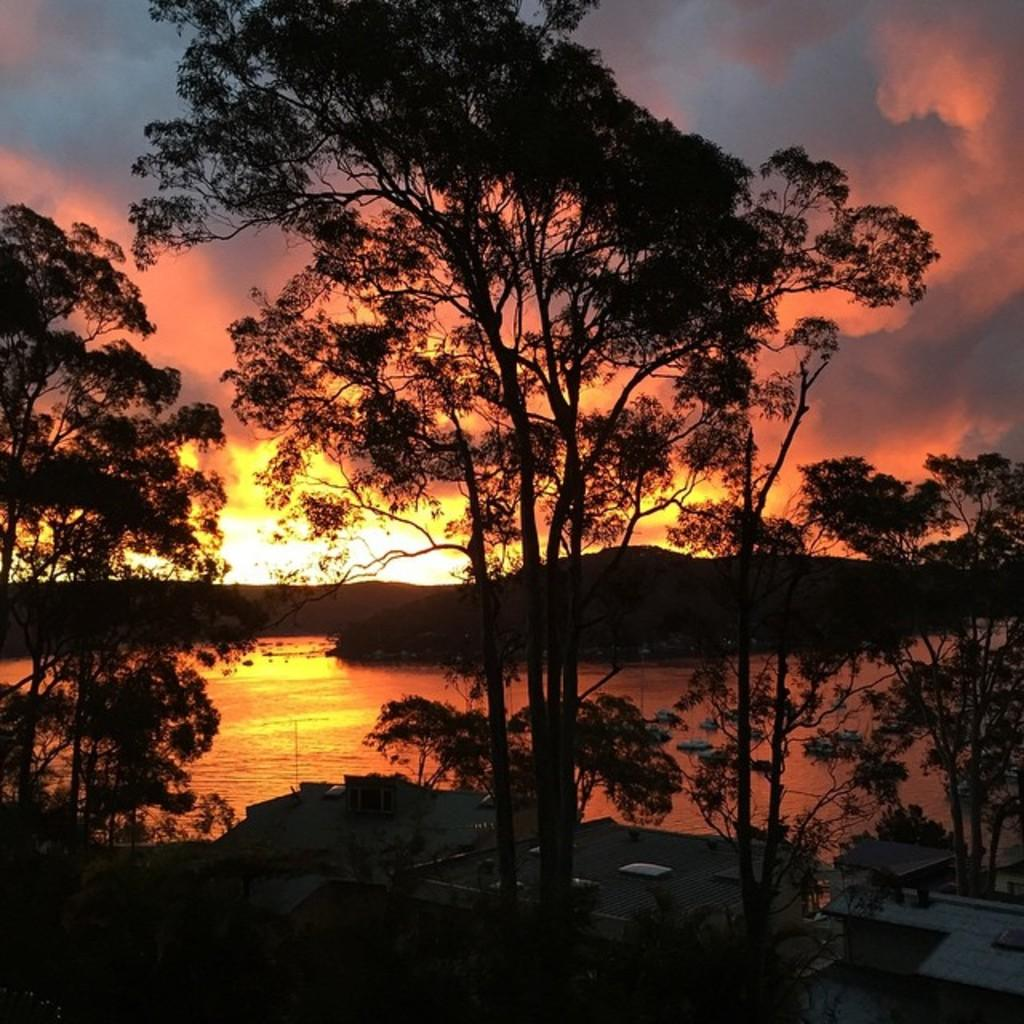What type of natural vegetation is present in the image? There is a group of trees in the image. What type of man-made structures can be seen in the image? There are buildings in the image. What type of geological formation is visible in the image? There are mountains in the image. What is the condition of the sky in the image? The sky is cloudy in the image. Reasoning: Let's think step by step by breaking down the image into its main components. We start by identifying the natural elements, which include the group of trees. Then, we move on to the man-made structures, which are the buildings. Next, we identify the geological formation, which is the mountains. Finally, we describe the sky's condition, which is cloudy. Each question is designed to elicit a specific detail about the image that is known from the provided facts. Absurd Question/Answer: Where are the quartz rocks located in the image? There is no mention of quartz rocks in the image, so we cannot determine their location. What type of thrilling activity is taking place in the image? There is no indication of any thrilling activity in the image; it primarily features trees, buildings, mountains, and a cloudy sky. 